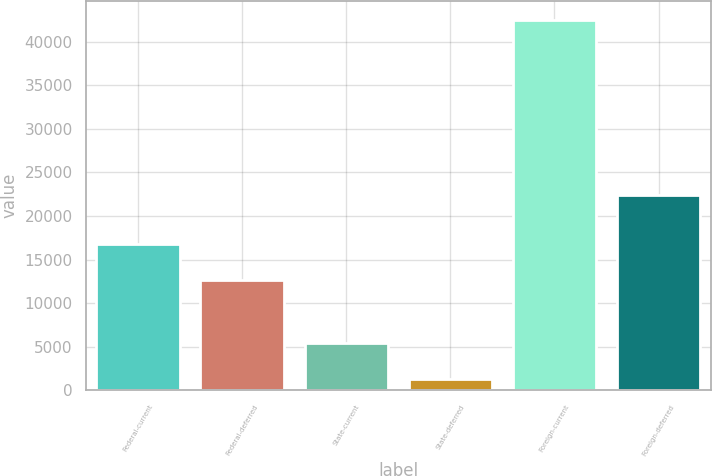Convert chart. <chart><loc_0><loc_0><loc_500><loc_500><bar_chart><fcel>Federal-current<fcel>Federal-deferred<fcel>State-current<fcel>State-deferred<fcel>Foreign-current<fcel>Foreign-deferred<nl><fcel>16780.6<fcel>12655<fcel>5401.6<fcel>1276<fcel>42532<fcel>22439<nl></chart> 